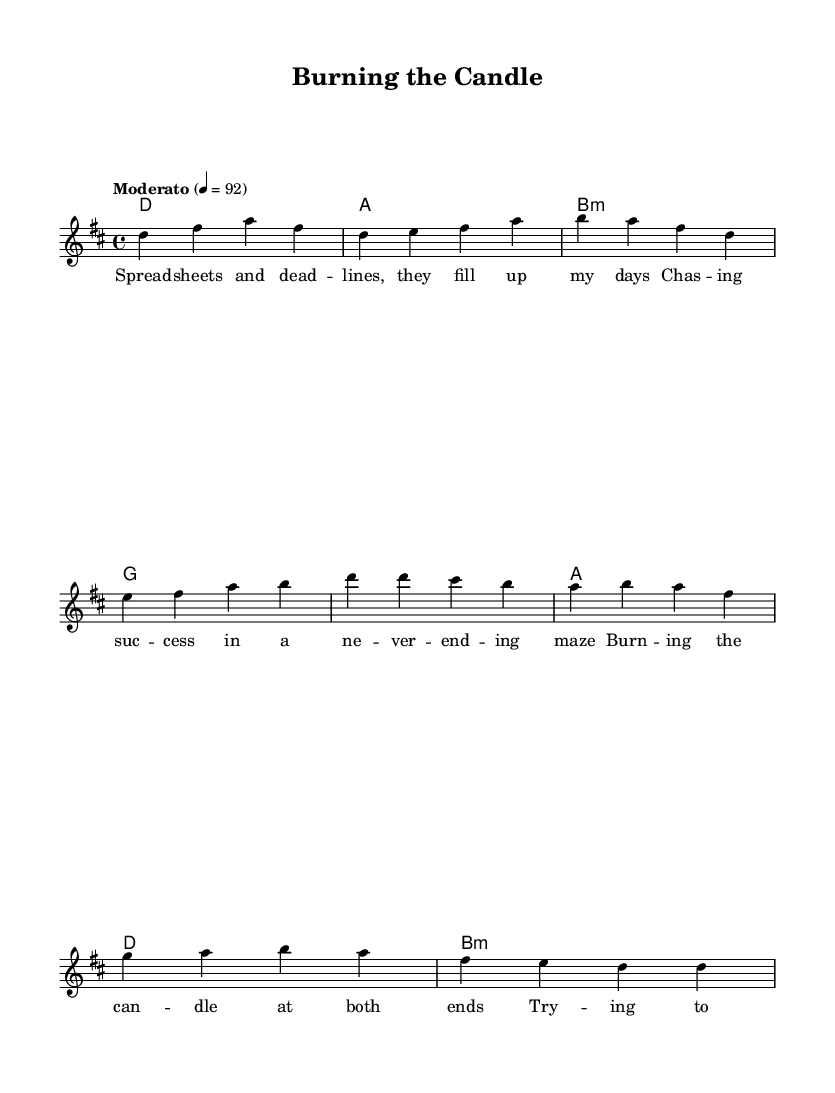What is the key signature of this music? The key signature is indicated by the 'd' in the global settings, which denotes D major. D major has two sharps (F# and C#) that are visually implied through the key notation.
Answer: D major What is the time signature of the piece? The time signature is specified in the global settings as "4/4", meaning there are four beats in each measure and a quarter note receives one beat.
Answer: 4/4 What is the tempo marking for this piece? The tempo marking is found in the global settings saying "Moderato" with a metronome marking of 92 beats per minute, indicating a moderate pace.
Answer: Moderato, 92 How many measures are in the verse section? The verse consists of two lines of music, and counting the measures shown, there are four measures represented in the rendered music for the verse section.
Answer: Four What is the chord progression for the chorus? To find the chords in the chorus, one can observe the sections of the harmonies. The chorus uses the chords G, A, D, and B minor. By analyzing the character sequence, the understanding is derived from the chord mode indicated in the music.
Answer: G A D B minor What lyrical theme is reflected in the verse? The theme presented in the verse suggests a struggle with work-life balance amidst workloads and deadlines, focusing on daily tasks and the pursuit of success. Listening to the lyrics reveals concerns about a never-ending maze.
Answer: Work-life balance How does the melody change between the verse and the chorus? Analyzing the melody, the verse uses a combination of descending and ascending notes, while the chorus presents a melody that is more straightforward and tends to have repeated notes, creating a contrasting dynamic. This indicates a shift in emotional intensity translating into the song structure typical of rock ballads.
Answer: More straightforward 